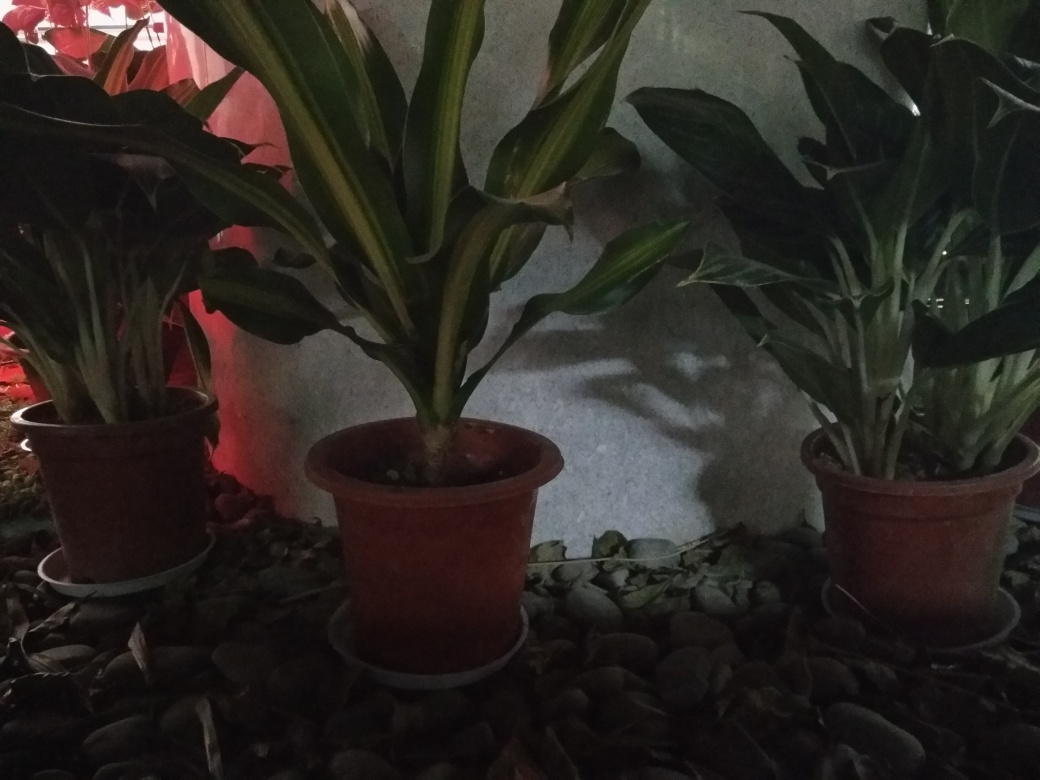Can you describe the types of plants in the photo? The plants in the photo appear to be Dracaena, recognizable by their long, broad leaves with distinctive white or yellow stripes along the edges or center. They are well-suited for indoors and have air-purifying qualities. 